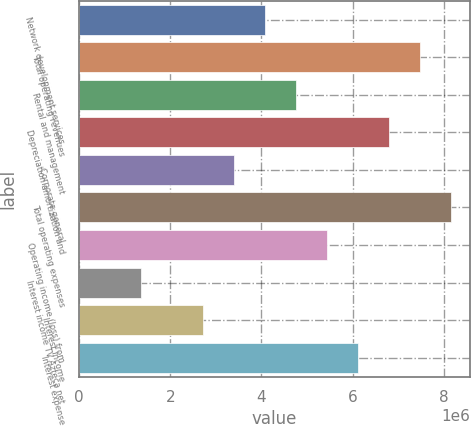Convert chart to OTSL. <chart><loc_0><loc_0><loc_500><loc_500><bar_chart><fcel>Network development services<fcel>Total operating revenues<fcel>Rental and management<fcel>Depreciation amortization and<fcel>Corporate general<fcel>Total operating expenses<fcel>Operating income (loss) from<fcel>Interest income TV Azteca net<fcel>Interest income<fcel>Interest expense<nl><fcel>4.08089e+06<fcel>7.48163e+06<fcel>4.76104e+06<fcel>6.80148e+06<fcel>3.40074e+06<fcel>8.16178e+06<fcel>5.44119e+06<fcel>1.3603e+06<fcel>2.72059e+06<fcel>6.12133e+06<nl></chart> 